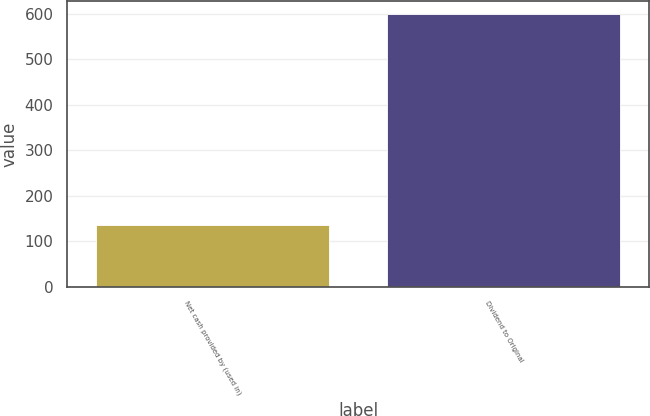<chart> <loc_0><loc_0><loc_500><loc_500><bar_chart><fcel>Net cash provided by (used in)<fcel>Dividend to Original<nl><fcel>135<fcel>599<nl></chart> 